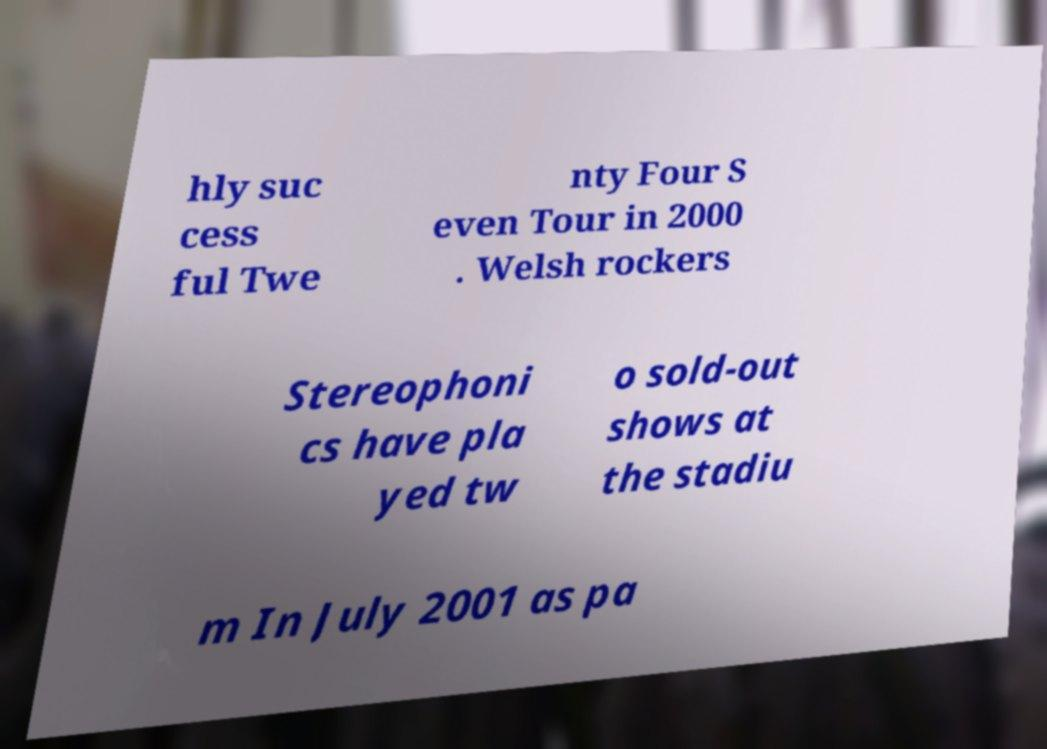For documentation purposes, I need the text within this image transcribed. Could you provide that? hly suc cess ful Twe nty Four S even Tour in 2000 . Welsh rockers Stereophoni cs have pla yed tw o sold-out shows at the stadiu m In July 2001 as pa 